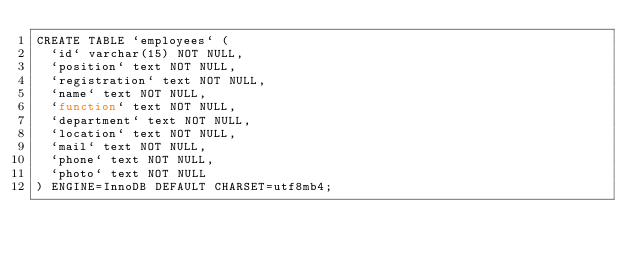Convert code to text. <code><loc_0><loc_0><loc_500><loc_500><_SQL_>CREATE TABLE `employees` (
  `id` varchar(15) NOT NULL,
  `position` text NOT NULL,
  `registration` text NOT NULL,
  `name` text NOT NULL,
  `function` text NOT NULL,
  `department` text NOT NULL,
  `location` text NOT NULL,
  `mail` text NOT NULL,
  `phone` text NOT NULL,
  `photo` text NOT NULL
) ENGINE=InnoDB DEFAULT CHARSET=utf8mb4;</code> 